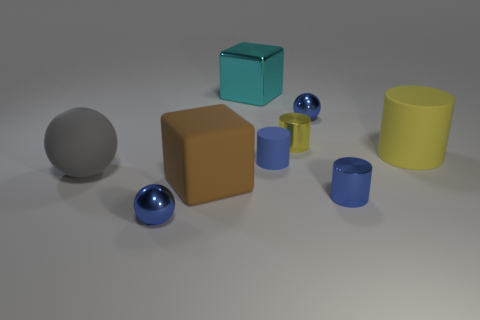Is the number of cylinders greater than the number of objects?
Offer a terse response. No. Is there any other thing that is the same color as the big shiny thing?
Your answer should be very brief. No. There is a brown object that is made of the same material as the big yellow cylinder; what is its shape?
Ensure brevity in your answer.  Cube. What is the material of the tiny blue cylinder that is behind the brown object in front of the tiny yellow shiny object?
Give a very brief answer. Rubber. Does the tiny blue object behind the small yellow metal object have the same shape as the gray rubber thing?
Keep it short and to the point. Yes. Are there more cylinders that are behind the big brown object than large cylinders?
Provide a succinct answer. Yes. The tiny thing that is the same color as the large cylinder is what shape?
Provide a succinct answer. Cylinder. What number of cubes are either tiny shiny objects or big yellow matte things?
Give a very brief answer. 0. What is the color of the tiny sphere that is in front of the tiny blue ball on the right side of the big brown rubber object?
Offer a terse response. Blue. Is the color of the large shiny block the same as the small ball behind the yellow metallic cylinder?
Ensure brevity in your answer.  No. 